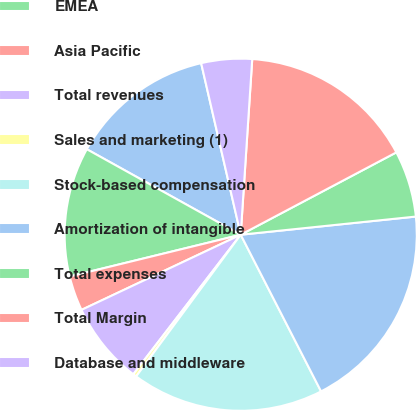Convert chart. <chart><loc_0><loc_0><loc_500><loc_500><pie_chart><fcel>Americas<fcel>EMEA<fcel>Asia Pacific<fcel>Total revenues<fcel>Sales and marketing (1)<fcel>Stock-based compensation<fcel>Amortization of intangible<fcel>Total expenses<fcel>Total Margin<fcel>Database and middleware<nl><fcel>13.32%<fcel>11.88%<fcel>3.21%<fcel>7.54%<fcel>0.32%<fcel>17.66%<fcel>19.1%<fcel>6.1%<fcel>16.21%<fcel>4.65%<nl></chart> 